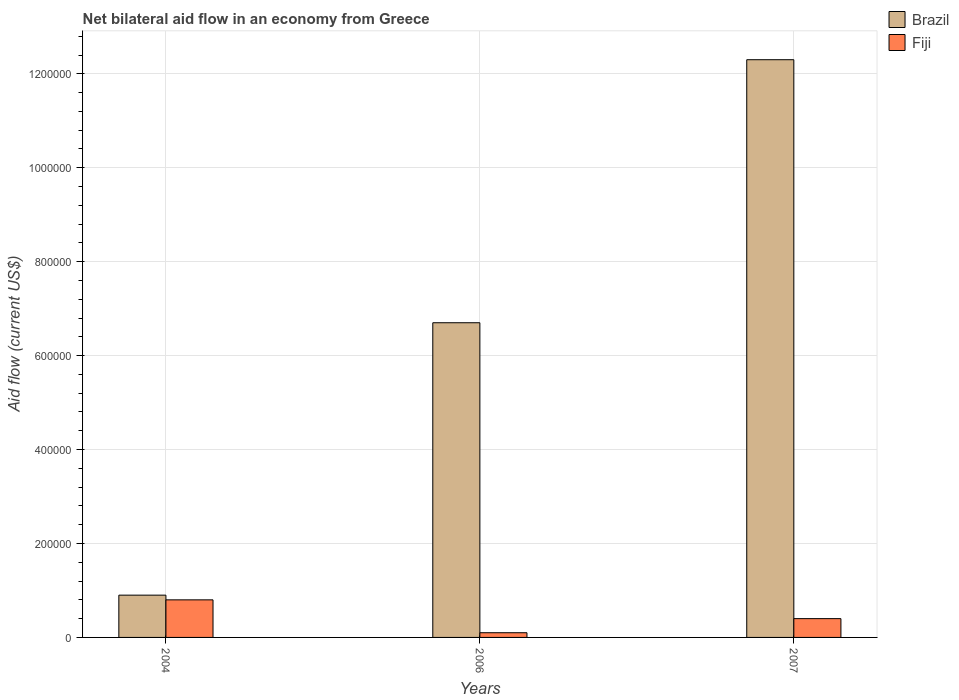How many different coloured bars are there?
Your answer should be very brief. 2. How many groups of bars are there?
Your answer should be compact. 3. What is the label of the 2nd group of bars from the left?
Offer a very short reply. 2006. What is the net bilateral aid flow in Brazil in 2007?
Provide a short and direct response. 1.23e+06. Across all years, what is the maximum net bilateral aid flow in Fiji?
Provide a short and direct response. 8.00e+04. Across all years, what is the minimum net bilateral aid flow in Fiji?
Offer a terse response. 10000. In which year was the net bilateral aid flow in Fiji minimum?
Offer a very short reply. 2006. What is the difference between the net bilateral aid flow in Brazil in 2004 and that in 2006?
Offer a very short reply. -5.80e+05. What is the difference between the net bilateral aid flow in Brazil in 2007 and the net bilateral aid flow in Fiji in 2004?
Ensure brevity in your answer.  1.15e+06. What is the average net bilateral aid flow in Fiji per year?
Keep it short and to the point. 4.33e+04. In the year 2007, what is the difference between the net bilateral aid flow in Fiji and net bilateral aid flow in Brazil?
Offer a very short reply. -1.19e+06. What is the difference between the highest and the second highest net bilateral aid flow in Brazil?
Keep it short and to the point. 5.60e+05. What is the difference between the highest and the lowest net bilateral aid flow in Brazil?
Provide a succinct answer. 1.14e+06. Is the sum of the net bilateral aid flow in Fiji in 2006 and 2007 greater than the maximum net bilateral aid flow in Brazil across all years?
Provide a succinct answer. No. What does the 2nd bar from the right in 2004 represents?
Provide a short and direct response. Brazil. How many bars are there?
Provide a succinct answer. 6. How many years are there in the graph?
Your response must be concise. 3. What is the difference between two consecutive major ticks on the Y-axis?
Provide a succinct answer. 2.00e+05. Does the graph contain any zero values?
Give a very brief answer. No. Does the graph contain grids?
Offer a terse response. Yes. Where does the legend appear in the graph?
Give a very brief answer. Top right. How many legend labels are there?
Give a very brief answer. 2. What is the title of the graph?
Your response must be concise. Net bilateral aid flow in an economy from Greece. What is the label or title of the X-axis?
Your answer should be compact. Years. What is the Aid flow (current US$) in Brazil in 2004?
Your response must be concise. 9.00e+04. What is the Aid flow (current US$) in Brazil in 2006?
Your answer should be very brief. 6.70e+05. What is the Aid flow (current US$) of Fiji in 2006?
Provide a succinct answer. 10000. What is the Aid flow (current US$) of Brazil in 2007?
Keep it short and to the point. 1.23e+06. Across all years, what is the maximum Aid flow (current US$) of Brazil?
Give a very brief answer. 1.23e+06. Across all years, what is the minimum Aid flow (current US$) of Brazil?
Your response must be concise. 9.00e+04. What is the total Aid flow (current US$) of Brazil in the graph?
Your response must be concise. 1.99e+06. What is the difference between the Aid flow (current US$) of Brazil in 2004 and that in 2006?
Your response must be concise. -5.80e+05. What is the difference between the Aid flow (current US$) of Brazil in 2004 and that in 2007?
Keep it short and to the point. -1.14e+06. What is the difference between the Aid flow (current US$) in Fiji in 2004 and that in 2007?
Give a very brief answer. 4.00e+04. What is the difference between the Aid flow (current US$) in Brazil in 2006 and that in 2007?
Offer a very short reply. -5.60e+05. What is the difference between the Aid flow (current US$) of Fiji in 2006 and that in 2007?
Provide a succinct answer. -3.00e+04. What is the difference between the Aid flow (current US$) in Brazil in 2006 and the Aid flow (current US$) in Fiji in 2007?
Your answer should be very brief. 6.30e+05. What is the average Aid flow (current US$) of Brazil per year?
Provide a succinct answer. 6.63e+05. What is the average Aid flow (current US$) of Fiji per year?
Offer a terse response. 4.33e+04. In the year 2007, what is the difference between the Aid flow (current US$) in Brazil and Aid flow (current US$) in Fiji?
Your response must be concise. 1.19e+06. What is the ratio of the Aid flow (current US$) of Brazil in 2004 to that in 2006?
Give a very brief answer. 0.13. What is the ratio of the Aid flow (current US$) in Brazil in 2004 to that in 2007?
Provide a succinct answer. 0.07. What is the ratio of the Aid flow (current US$) of Brazil in 2006 to that in 2007?
Give a very brief answer. 0.54. What is the ratio of the Aid flow (current US$) of Fiji in 2006 to that in 2007?
Your answer should be very brief. 0.25. What is the difference between the highest and the second highest Aid flow (current US$) in Brazil?
Offer a very short reply. 5.60e+05. What is the difference between the highest and the second highest Aid flow (current US$) of Fiji?
Provide a short and direct response. 4.00e+04. What is the difference between the highest and the lowest Aid flow (current US$) of Brazil?
Your response must be concise. 1.14e+06. 